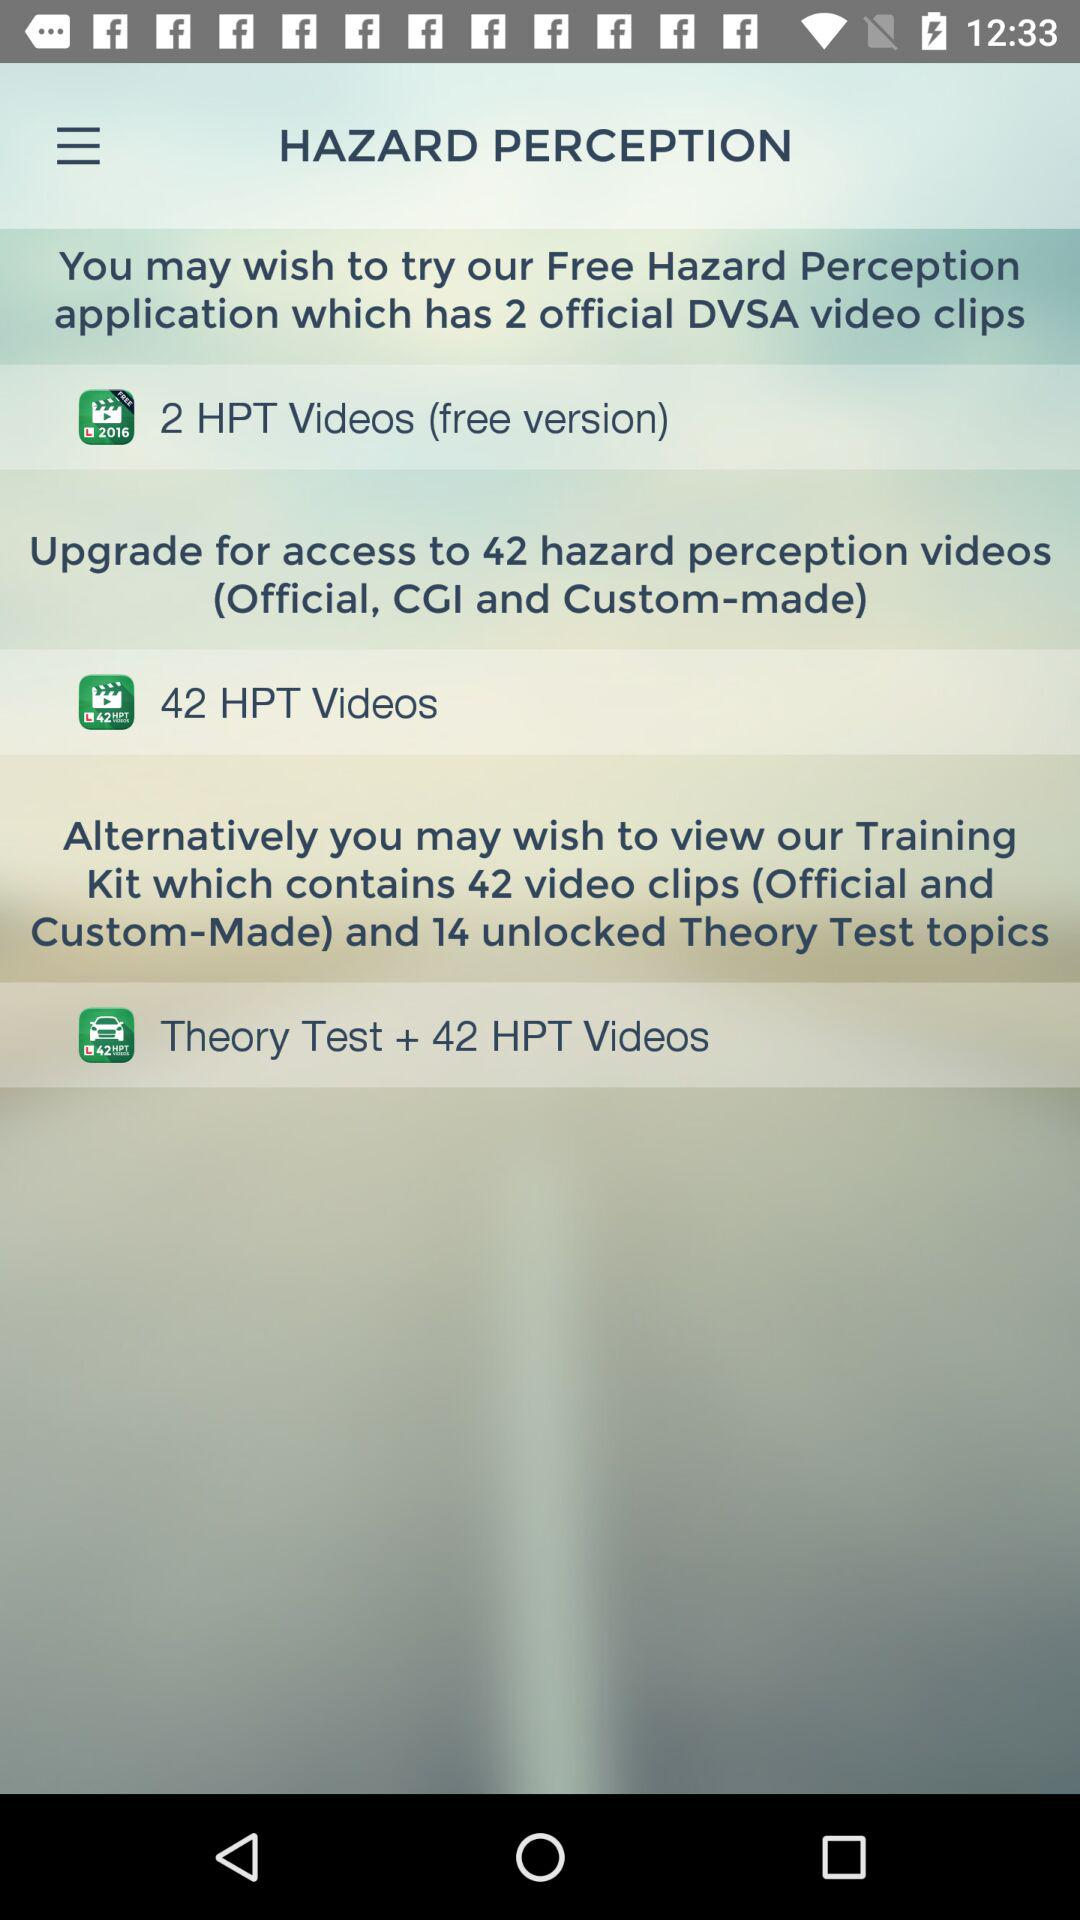How many more HPT videos are available in the Training Kit than in the Free Hazard Perception application?
Answer the question using a single word or phrase. 40 